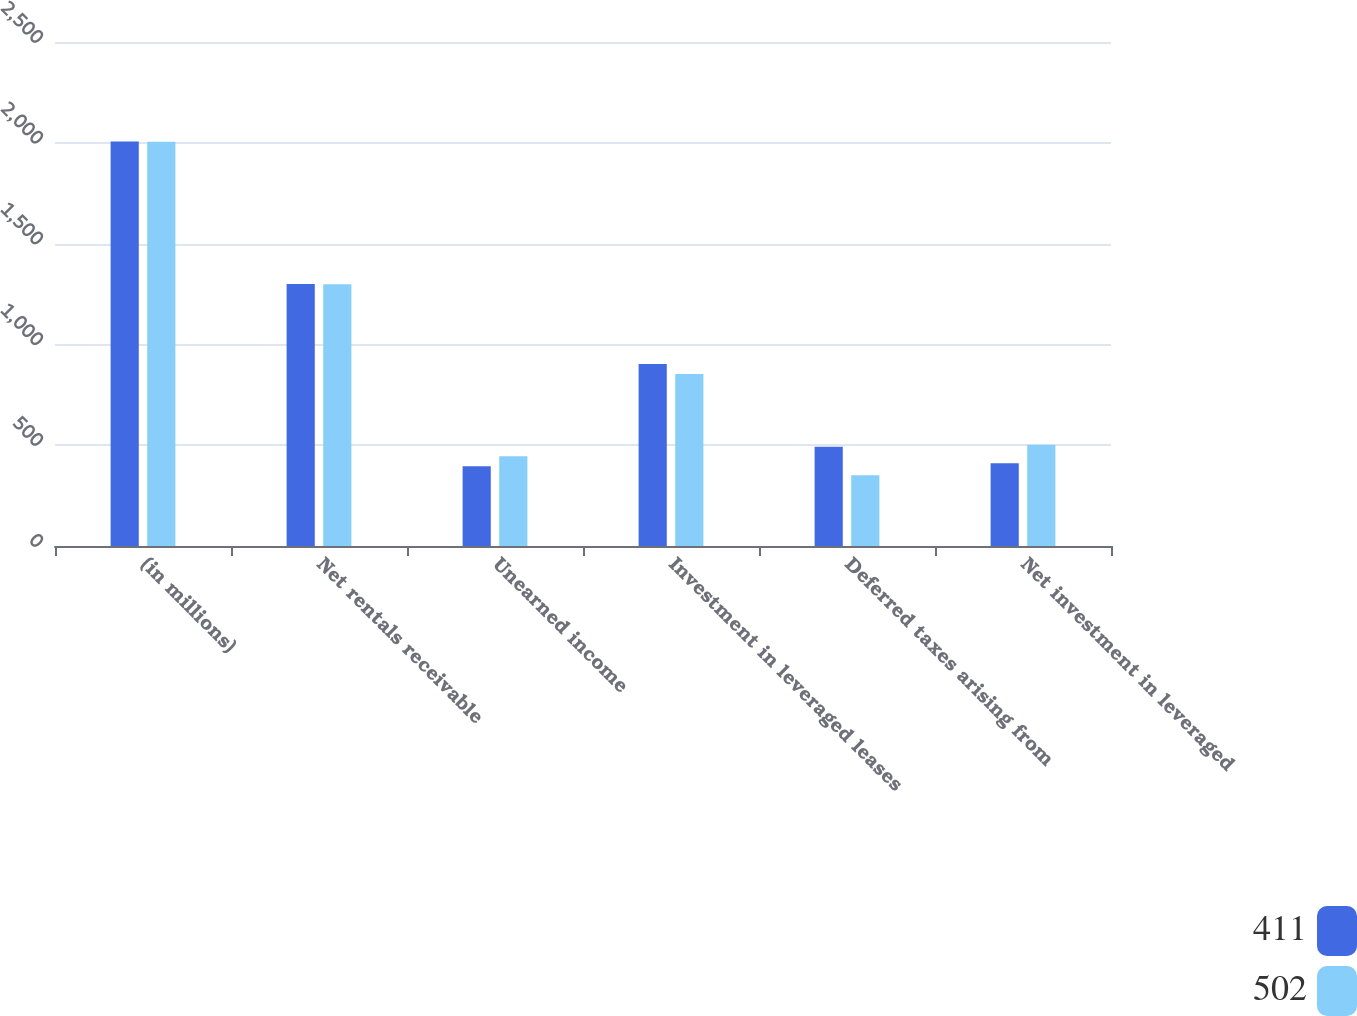Convert chart to OTSL. <chart><loc_0><loc_0><loc_500><loc_500><stacked_bar_chart><ecel><fcel>(in millions)<fcel>Net rentals receivable<fcel>Unearned income<fcel>Investment in leveraged leases<fcel>Deferred taxes arising from<fcel>Net investment in leveraged<nl><fcel>411<fcel>2006<fcel>1299<fcel>396<fcel>903<fcel>492<fcel>411<nl><fcel>502<fcel>2005<fcel>1298<fcel>445<fcel>853<fcel>351<fcel>502<nl></chart> 